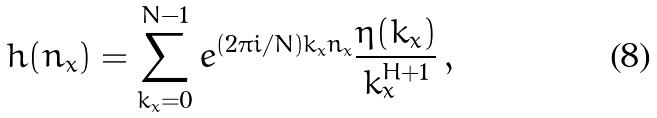Convert formula to latex. <formula><loc_0><loc_0><loc_500><loc_500>h ( n _ { x } ) = \sum _ { k _ { x } = 0 } ^ { N - 1 } e ^ { ( 2 \pi i / N ) k _ { x } n _ { x } } \frac { \eta ( k _ { x } ) } { k _ { x } ^ { H + 1 } } \, ,</formula> 